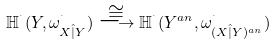<formula> <loc_0><loc_0><loc_500><loc_500>\mathbb { H } ^ { ^ { . } } ( Y , \omega ^ { ^ { . } } _ { X \hat { | } Y } ) \stackrel { \cong } { \longrightarrow } \mathbb { H } ^ { ^ { . } } ( Y ^ { a n } , \omega ^ { ^ { . } } _ { ( X \hat { | } Y ) ^ { a n } } )</formula> 